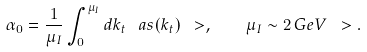Convert formula to latex. <formula><loc_0><loc_0><loc_500><loc_500>\alpha _ { 0 } = \frac { 1 } { \mu _ { I } } \int _ { 0 } ^ { \mu _ { I } } d k _ { t } \, \ a s ( k _ { t } ) \ > , \quad \mu _ { I } \sim 2 \, G e V \ > .</formula> 